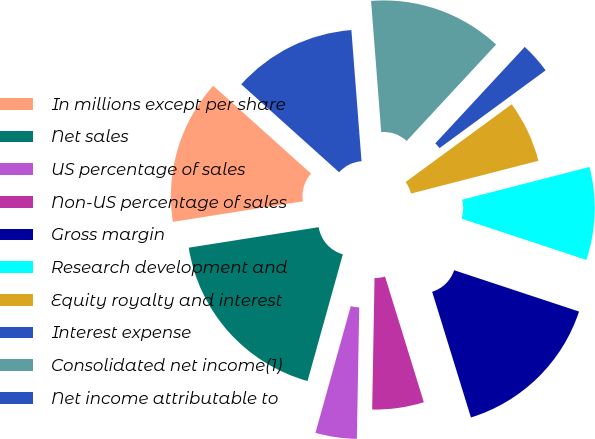<chart> <loc_0><loc_0><loc_500><loc_500><pie_chart><fcel>In millions except per share<fcel>Net sales<fcel>US percentage of sales<fcel>Non-US percentage of sales<fcel>Gross margin<fcel>Research development and<fcel>Equity royalty and interest<fcel>Interest expense<fcel>Consolidated net income(1)<fcel>Net income attributable to<nl><fcel>14.14%<fcel>18.18%<fcel>4.04%<fcel>5.05%<fcel>15.15%<fcel>9.09%<fcel>6.06%<fcel>3.03%<fcel>13.13%<fcel>12.12%<nl></chart> 